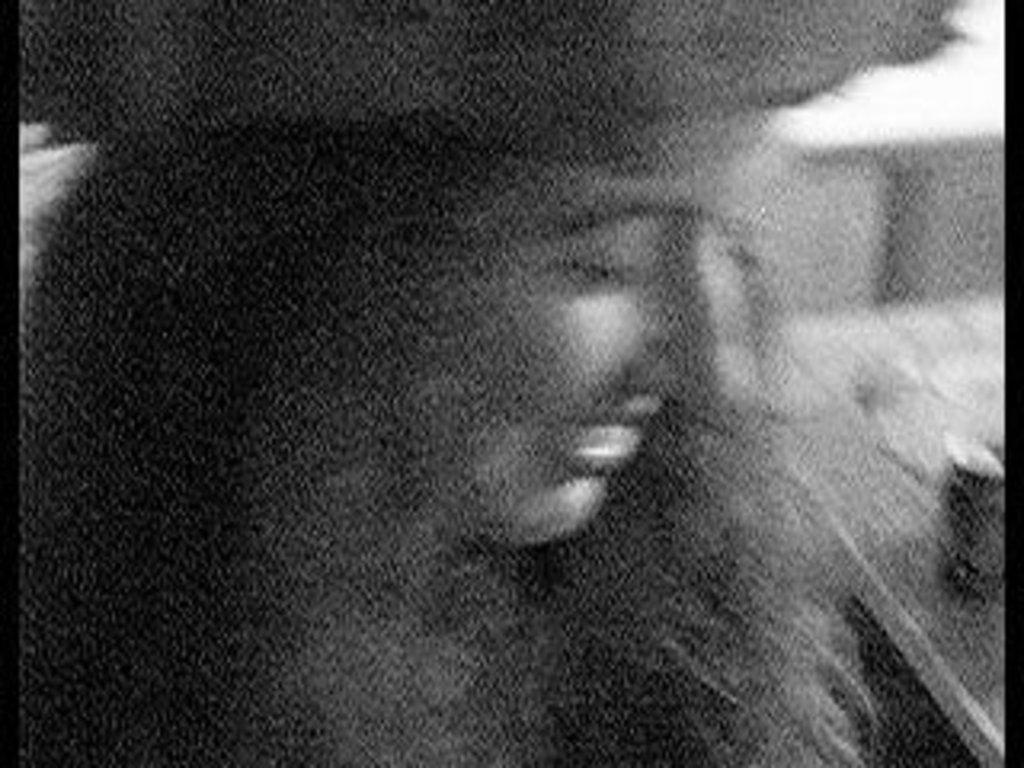Who is present in the image? There is a lady in the image. Can you describe the overall appearance of the image? The image is hazy. What rule does the boy break in the image? There is no boy present in the image, so it is not possible to determine if any rules are broken. 